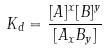Convert formula to latex. <formula><loc_0><loc_0><loc_500><loc_500>K _ { d } = \frac { [ A ] ^ { x } [ B ] ^ { y } } { [ A _ { x } B _ { y } ] }</formula> 